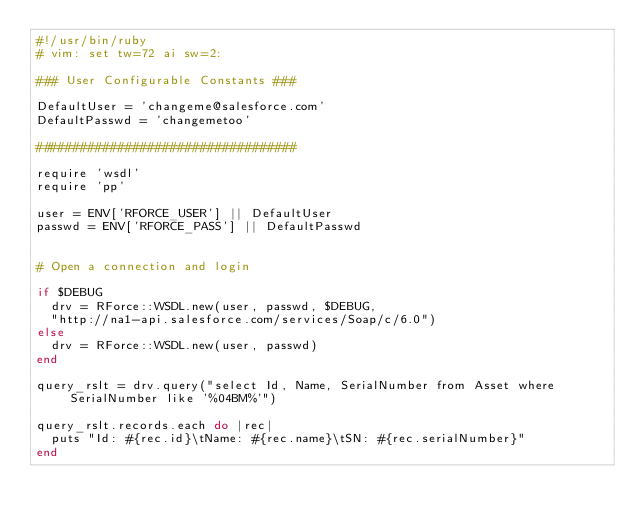<code> <loc_0><loc_0><loc_500><loc_500><_Ruby_>#!/usr/bin/ruby
# vim: set tw=72 ai sw=2:

### User Configurable Constants ###

DefaultUser = 'changeme@salesforce.com'
DefaultPasswd = 'changemetoo'

###################################

require 'wsdl'
require 'pp'

user = ENV['RFORCE_USER'] || DefaultUser
passwd = ENV['RFORCE_PASS'] || DefaultPasswd


# Open a connection and login

if $DEBUG
  drv = RForce::WSDL.new(user, passwd, $DEBUG, 
	"http://na1-api.salesforce.com/services/Soap/c/6.0")
else
  drv = RForce::WSDL.new(user, passwd)
end

query_rslt = drv.query("select Id, Name, SerialNumber from Asset where SerialNumber like '%04BM%'")

query_rslt.records.each do |rec|
  puts "Id: #{rec.id}\tName: #{rec.name}\tSN: #{rec.serialNumber}"
end
</code> 